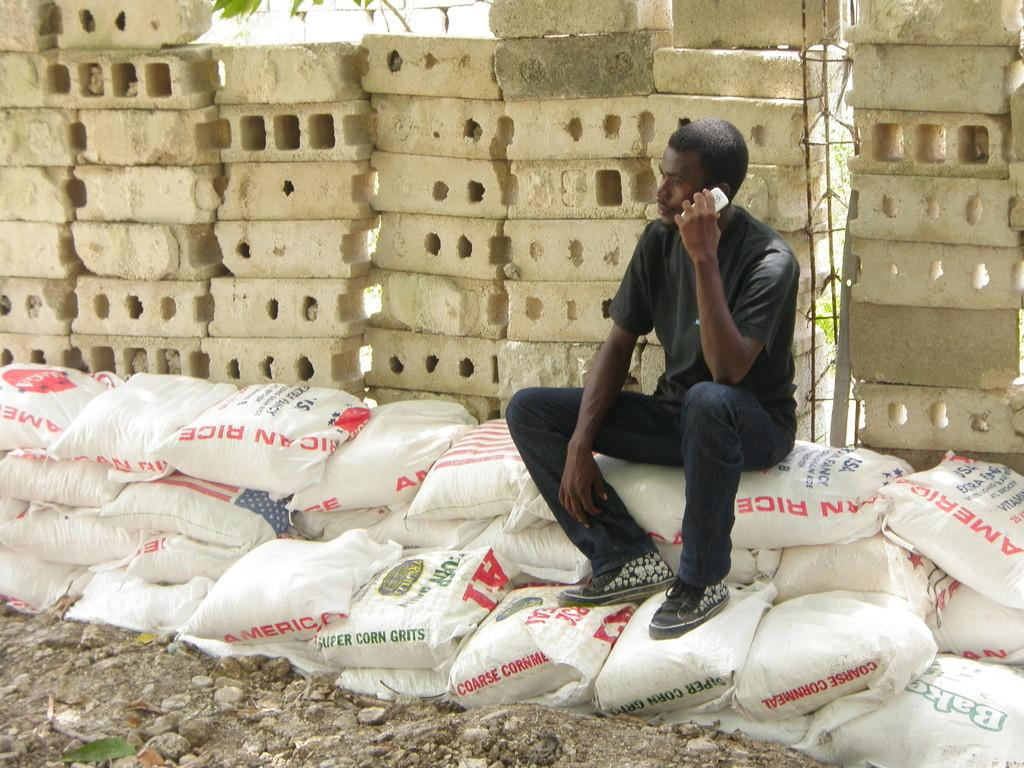What is the ethnicity of the man in the picture? The man in the picture is African. What is the man wearing in the picture? The man is wearing a black t-shirt. What is the man sitting on in the picture? The man is sitting on white bags. What is the man doing in the picture? The man is talking on the phone. What can be seen in the background of the picture? There is a polystyrene white block in the background. How many cups can be seen in the picture? There are no cups present in the picture. Is there a toad visible in the picture? There is no toad present in the picture. 